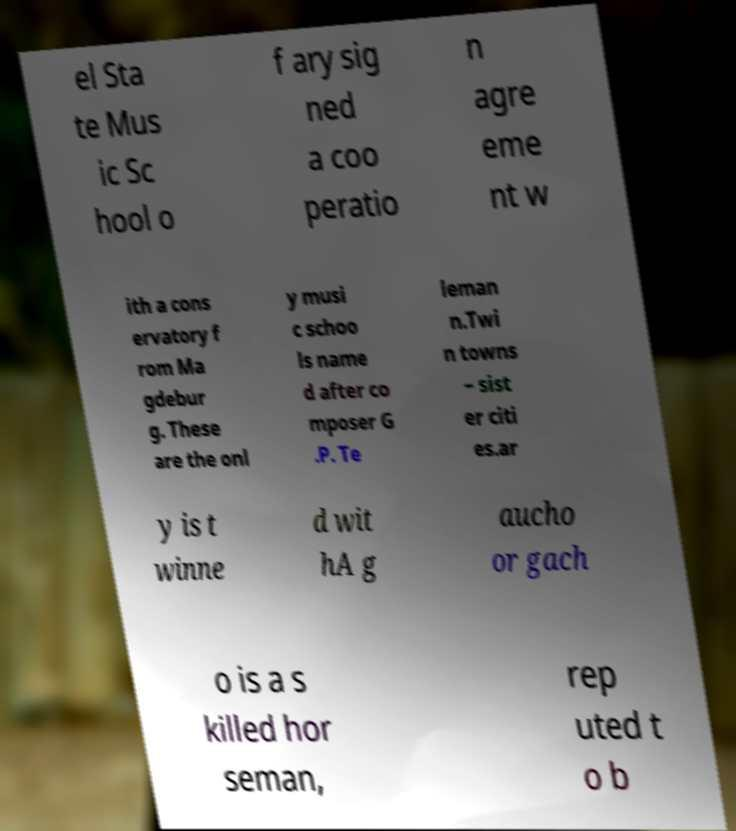I need the written content from this picture converted into text. Can you do that? el Sta te Mus ic Sc hool o f ary sig ned a coo peratio n agre eme nt w ith a cons ervatory f rom Ma gdebur g. These are the onl y musi c schoo ls name d after co mposer G .P. Te leman n.Twi n towns – sist er citi es.ar y is t winne d wit hA g aucho or gach o is a s killed hor seman, rep uted t o b 